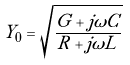<formula> <loc_0><loc_0><loc_500><loc_500>Y _ { 0 } = \sqrt { \frac { G + j \omega C } { R + j \omega L } }</formula> 